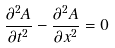<formula> <loc_0><loc_0><loc_500><loc_500>\frac { { { \partial ^ { 2 } } A } } { \partial t ^ { 2 } } - \frac { { { \partial ^ { 2 } } A } } { \partial x ^ { 2 } } = 0</formula> 